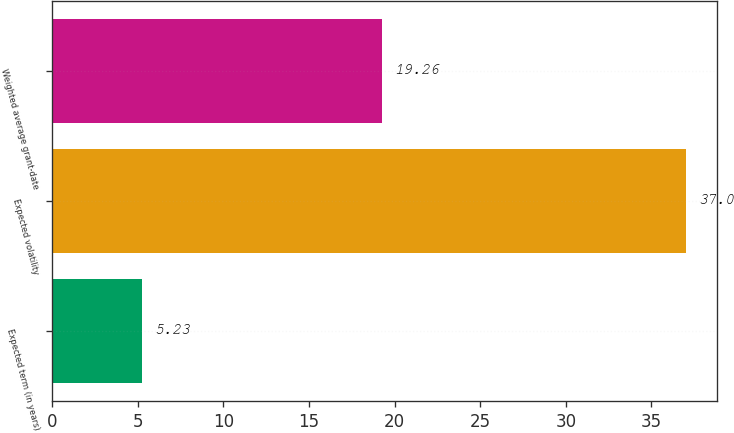<chart> <loc_0><loc_0><loc_500><loc_500><bar_chart><fcel>Expected term (in years)<fcel>Expected volatility<fcel>Weighted average grant-date<nl><fcel>5.23<fcel>37<fcel>19.26<nl></chart> 